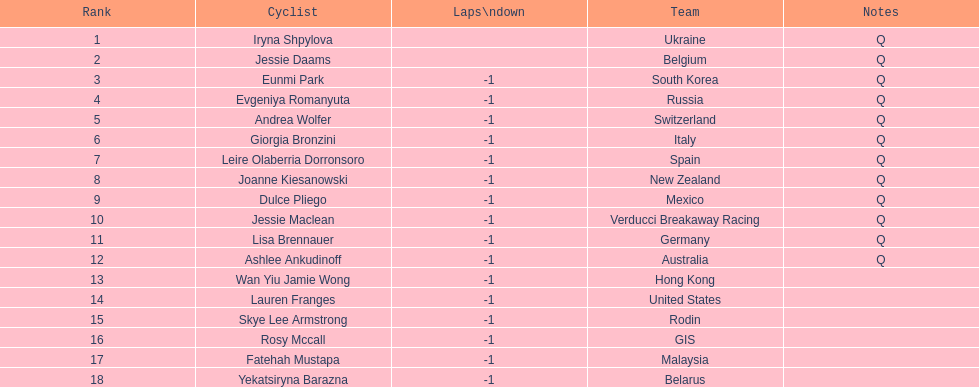What two cyclists come from teams with no laps down? Iryna Shpylova, Jessie Daams. 